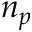Convert formula to latex. <formula><loc_0><loc_0><loc_500><loc_500>n _ { p }</formula> 